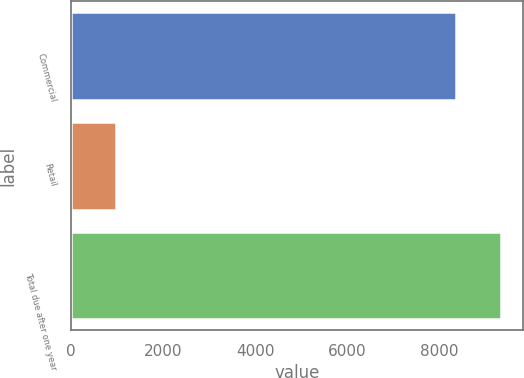<chart> <loc_0><loc_0><loc_500><loc_500><bar_chart><fcel>Commercial<fcel>Retail<fcel>Total due after one year<nl><fcel>8362.8<fcel>982.8<fcel>9345.6<nl></chart> 